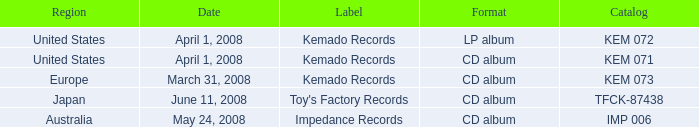Which Region has a Catalog of kem 072? United States. 